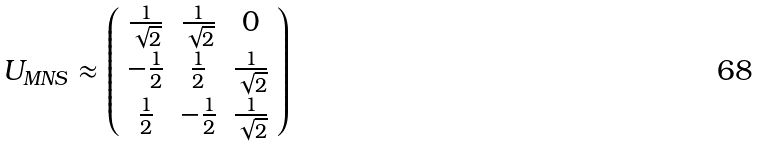<formula> <loc_0><loc_0><loc_500><loc_500>U _ { M N S } \approx \left ( \begin{array} { c c c } \frac { 1 } { \sqrt { 2 } } & \frac { 1 } { \sqrt { 2 } } & 0 \\ - \frac { 1 } { 2 } & \frac { 1 } { 2 } & \frac { 1 } { \sqrt { 2 } } \\ \frac { 1 } { 2 } & - \frac { 1 } { 2 } & \frac { 1 } { \sqrt { 2 } } \end{array} \right )</formula> 